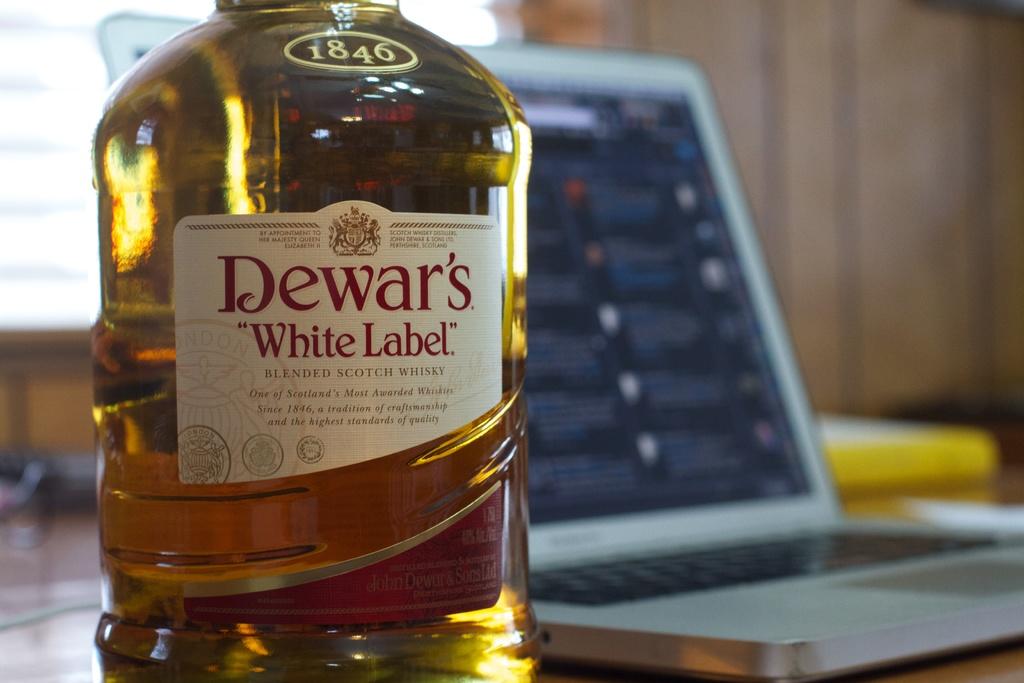What is the brand of this scotch?
Offer a terse response. Dewar's. 